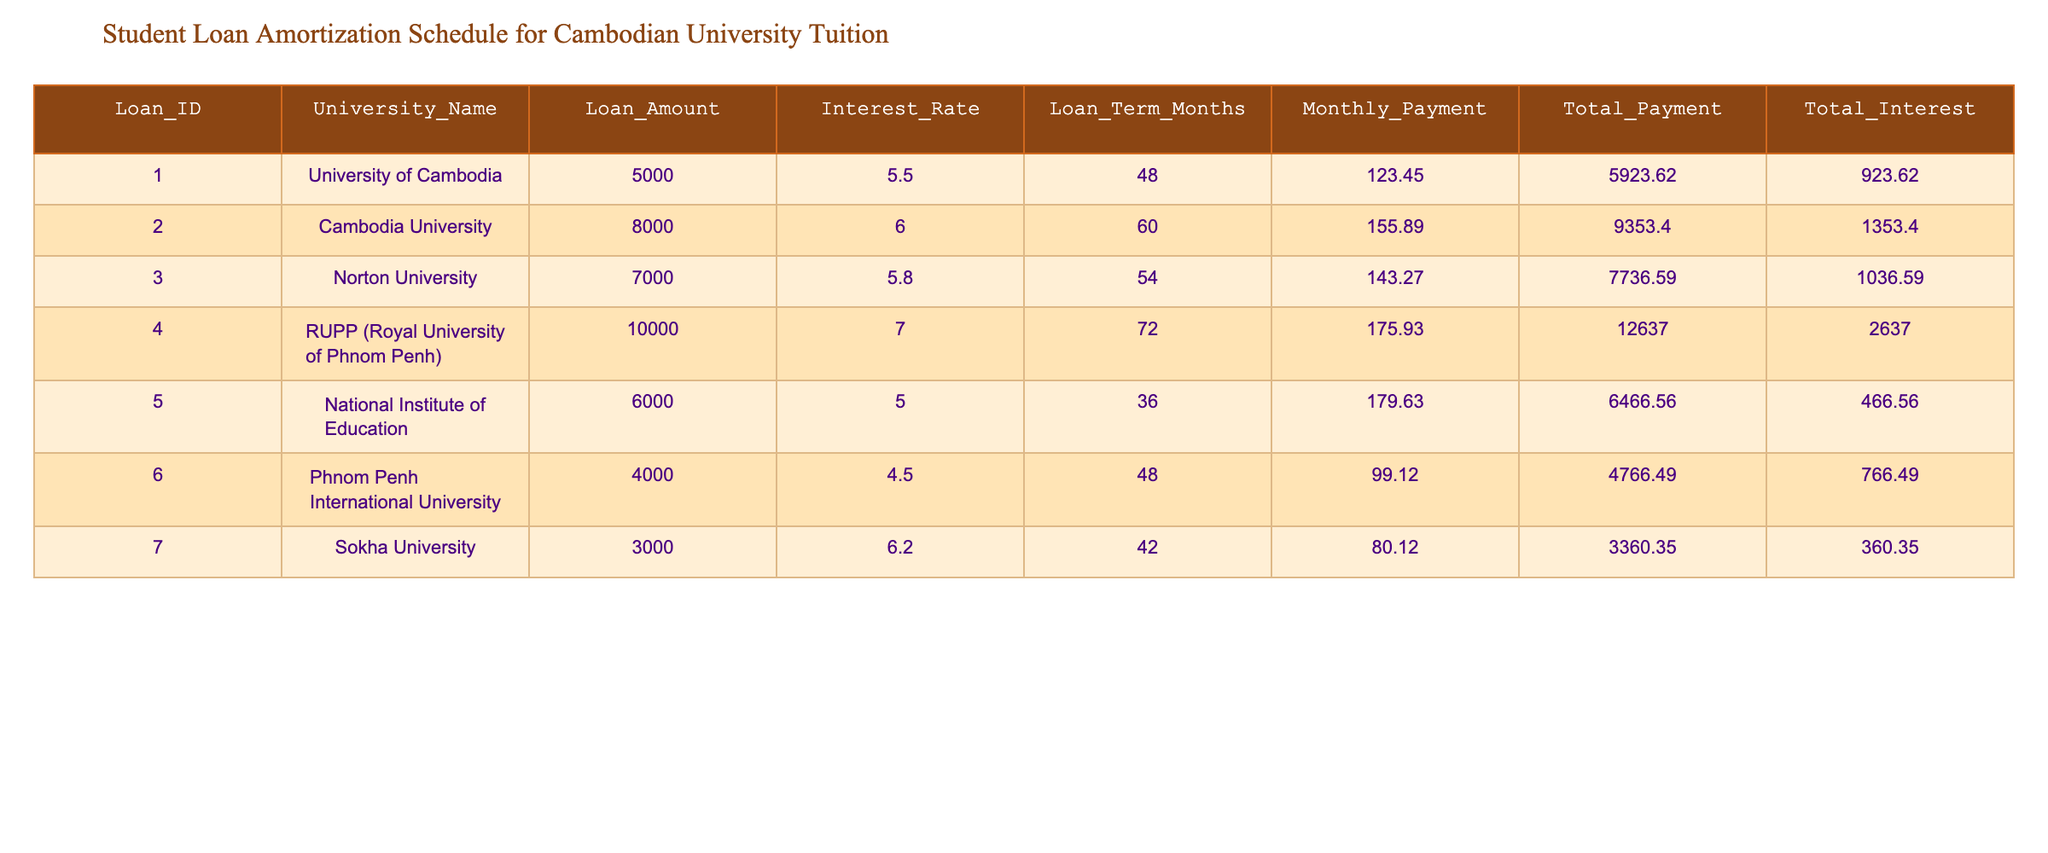What is the loan amount for the National Institute of Education? The loan amount for the National Institute of Education is clearly listed in the table under the "Loan Amount" column corresponding to its entry. It is 6000.
Answer: 6000 What is the total interest paid for the loan from the Royal University of Phnom Penh? The total interest paid is located in the table under the "Total Interest" column for the Royal University of Phnom Penh's loan entry, which shows 2637.00.
Answer: 2637.00 Which university has the highest Loan Amount? To determine which university has the highest loan amount, I compared all the values in the "Loan Amount" column. The Royal University of Phnom Penh has the highest loan amount at 10000.
Answer: Royal University of Phnom Penh What is the average monthly payment across all loans? First, I sum the monthly payments in the "Monthly Payment" column: 123.45 + 155.89 + 143.27 + 175.93 + 179.63 + 99.12 + 80.12 = 957.41. Then, I divide this sum by the number of loans (7) to find the average: 957.41 / 7 = 136.78.
Answer: 136.78 Is the interest rate for Phnom Penh International University lower than 5.5%? I check the "Interest Rate" for Phnom Penh International University in the table, which shows 4.5%. Since 4.5% is lower than 5.5%, the answer is yes.
Answer: Yes What is the difference in total payment between Cambodia University and Sokha University? I subtract the total payment for Sokha University (3360.35) from Cambodia University (9353.40): 9353.40 - 3360.35 = 5993.05.
Answer: 5993.05 Are the monthly payments for loans from Norton University and National Institute of Education equal? By examining the "Monthly Payment" column, I find that Norton University has a monthly payment of 143.27 and National Institute of Education has 179.63. Since they are not equal, the answer is no.
Answer: No How much total interest will be paid for the loan amount above 7000? I identify loans in the "Loan Amount" column that are above 7000, which are the Royal University of Phnom Penh (2637.00) and Cambodia University (1353.40). I sum these values: 2637.00 + 1353.40 = 3990.40.
Answer: 3990.40 What is the total payment for the loan with the highest interest rate? Looking at the "Interest Rate" column, I see that the Royal University of Phnom Penh has the highest interest rate of 7.0%. Its corresponding "Total Payment" in the table is 12637.00.
Answer: 12637.00 